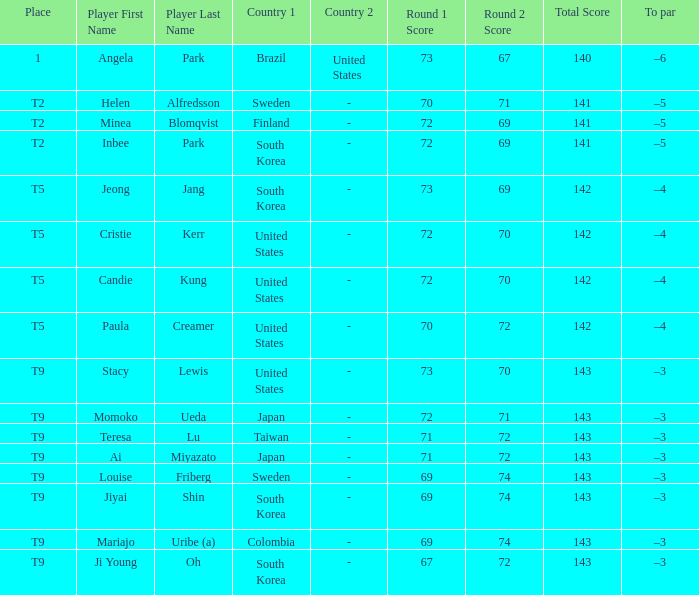Who placed t5 and had a score of 70-72=142? Paula Creamer. 